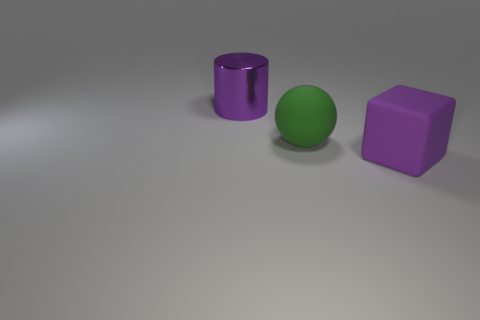What number of large objects are left of the purple object to the right of the large rubber ball?
Keep it short and to the point. 2. What number of purple objects are large metal cylinders or matte balls?
Your answer should be very brief. 1. What is the shape of the large rubber object behind the purple thing in front of the big rubber object on the left side of the purple cube?
Offer a very short reply. Sphere. What color is the metallic thing that is the same size as the purple matte thing?
Provide a short and direct response. Purple. There is a matte ball; is it the same size as the thing on the right side of the big green rubber object?
Give a very brief answer. Yes. There is a purple object that is to the right of the large purple cylinder that is behind the ball; what shape is it?
Offer a very short reply. Cube. Is the number of large green objects to the left of the ball less than the number of big yellow cubes?
Your answer should be compact. No. There is a large thing that is the same color as the metallic cylinder; what is its shape?
Offer a terse response. Cube. What number of other shiny cylinders are the same size as the metal cylinder?
Your answer should be compact. 0. What is the shape of the thing behind the large matte sphere?
Give a very brief answer. Cylinder. 